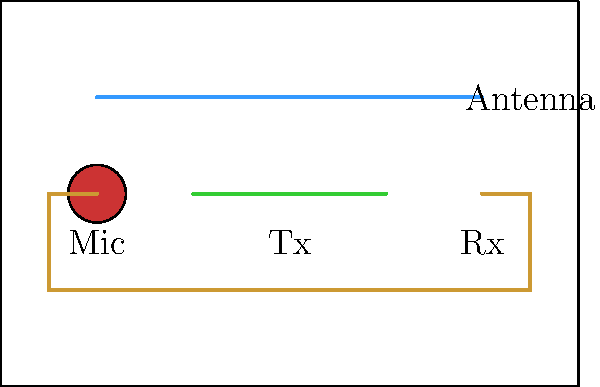In designing a simple wireless microphone system for a dance event, which component in the schematic is responsible for converting sound waves into electrical signals? To understand the function of each component in a simple wireless microphone system, let's break down the schematic:

1. Microphone (Mic): This is the input device that converts sound waves into electrical signals. It's typically a transducer that responds to acoustic pressure and converts it into an electrical voltage.

2. Transmitter (Tx): This component takes the electrical signal from the microphone and modulates it onto a radio frequency carrier wave. It then amplifies this signal and sends it to the antenna for transmission.

3. Wireless Signal: Represented by the wavy line, this is the radio frequency signal that carries the audio information through the air.

4. Antenna: This is the device that radiates the radio waves from the transmitter into the air.

5. Receiver (Rx): This component picks up the transmitted radio signal, demodulates it to recover the original audio signal, and sends it to an audio amplifier or sound system.

In this system, the microphone is the first component in the signal chain and is responsible for the initial conversion of sound waves into electrical signals. Without this conversion, the rest of the system would have no audio information to transmit.
Answer: Microphone (Mic) 